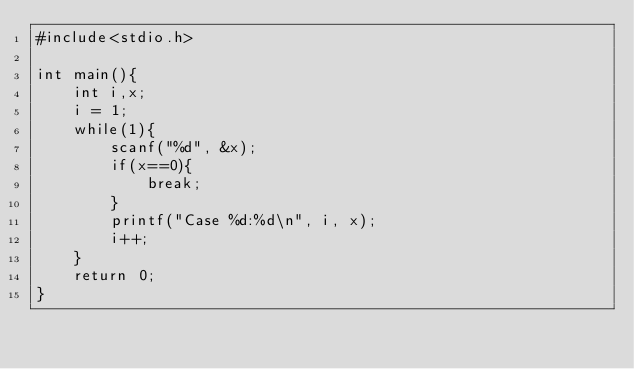<code> <loc_0><loc_0><loc_500><loc_500><_C_>#include<stdio.h>

int main(){
	int i,x;
	i = 1;
	while(1){
		scanf("%d", &x);
		if(x==0){
			break;
		}
		printf("Case %d:%d\n", i, x);
		i++;
	}
	return 0;
}</code> 